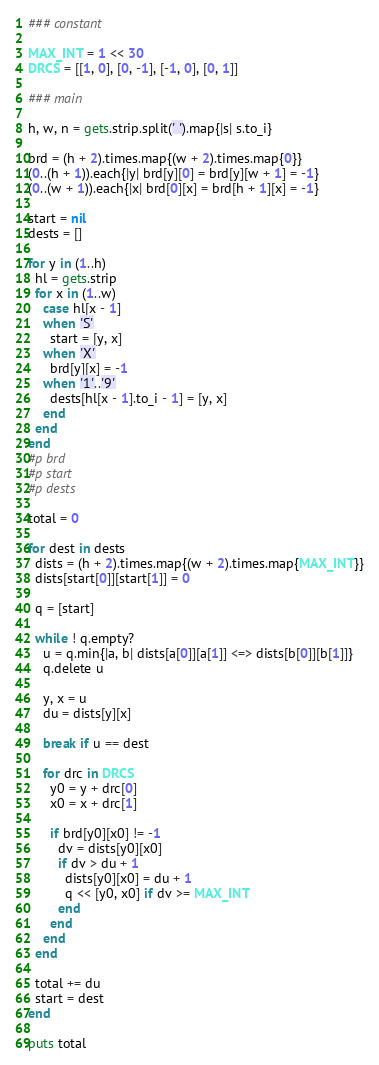Convert code to text. <code><loc_0><loc_0><loc_500><loc_500><_Ruby_>### constant

MAX_INT = 1 << 30
DRCS = [[1, 0], [0, -1], [-1, 0], [0, 1]]

### main

h, w, n = gets.strip.split(' ').map{|s| s.to_i}

brd = (h + 2).times.map{(w + 2).times.map{0}}
(0..(h + 1)).each{|y| brd[y][0] = brd[y][w + 1] = -1}
(0..(w + 1)).each{|x| brd[0][x] = brd[h + 1][x] = -1}

start = nil
dests = []

for y in (1..h)
  hl = gets.strip
  for x in (1..w)
    case hl[x - 1]
    when 'S'
      start = [y, x]
    when 'X'
      brd[y][x] = -1
    when '1'..'9'
      dests[hl[x - 1].to_i - 1] = [y, x]
    end
  end
end
#p brd
#p start
#p dests

total = 0

for dest in dests
  dists = (h + 2).times.map{(w + 2).times.map{MAX_INT}}
  dists[start[0]][start[1]] = 0

  q = [start]

  while ! q.empty?
    u = q.min{|a, b| dists[a[0]][a[1]] <=> dists[b[0]][b[1]]}
    q.delete u

    y, x = u
    du = dists[y][x]

    break if u == dest

    for drc in DRCS
      y0 = y + drc[0]
      x0 = x + drc[1]

      if brd[y0][x0] != -1
        dv = dists[y0][x0]
        if dv > du + 1
          dists[y0][x0] = du + 1
          q << [y0, x0] if dv >= MAX_INT
        end
      end
    end
  end

  total += du
  start = dest
end

puts total</code> 